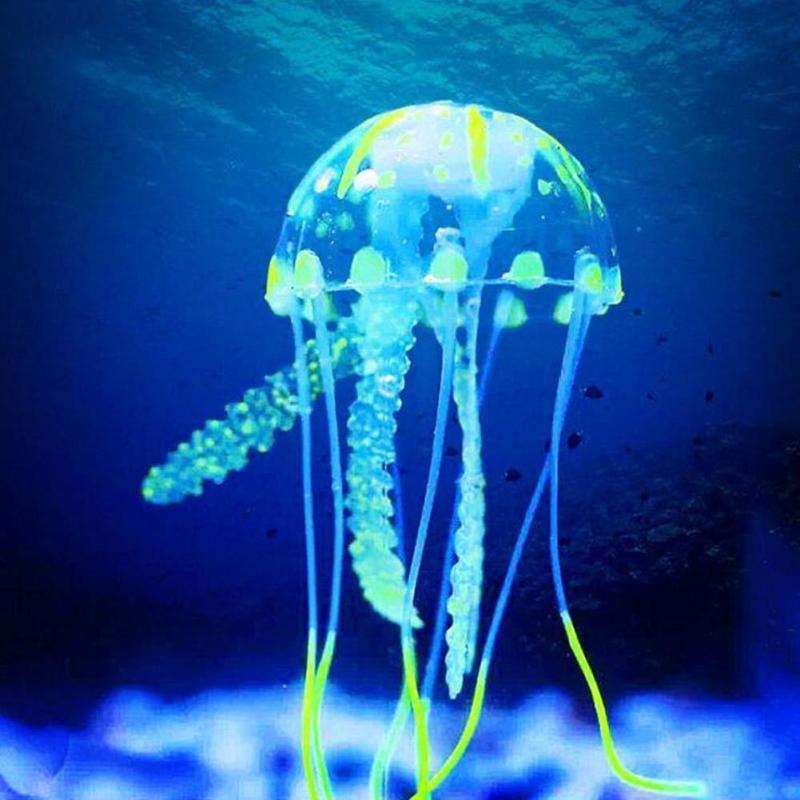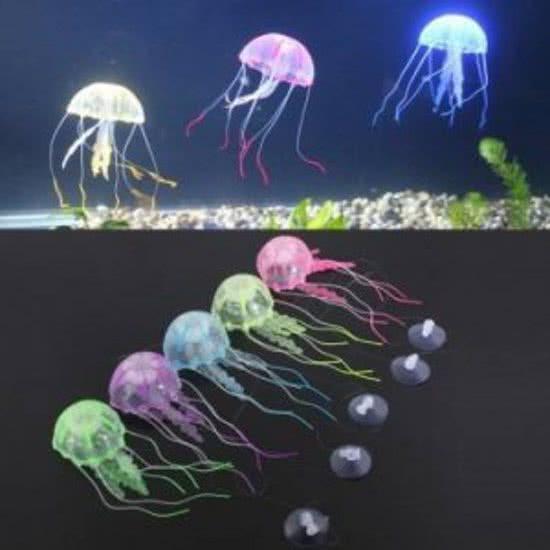The first image is the image on the left, the second image is the image on the right. For the images displayed, is the sentence "Right image shows a single mushroom-shaped jellyfish with at least some neon blue tones." factually correct? Answer yes or no. No. 